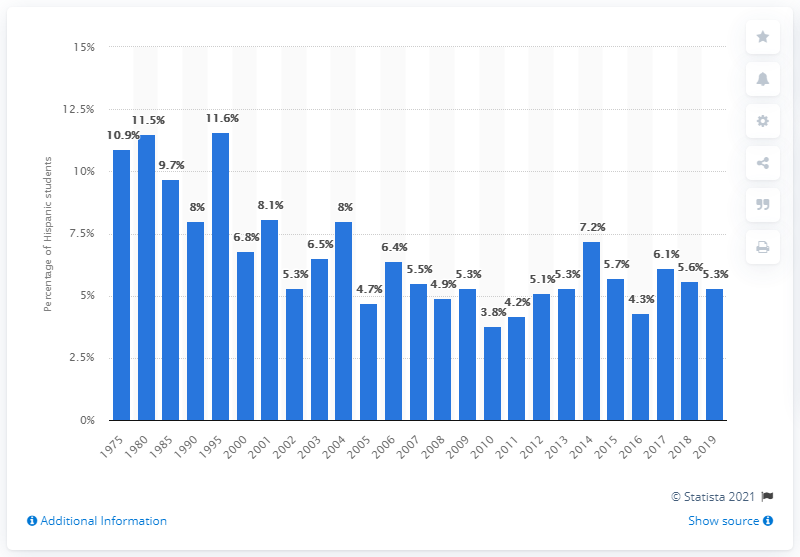Outline some significant characteristics in this image. In 2019, it was reported that 5.3% of Hispanic students dropped out of high school. 